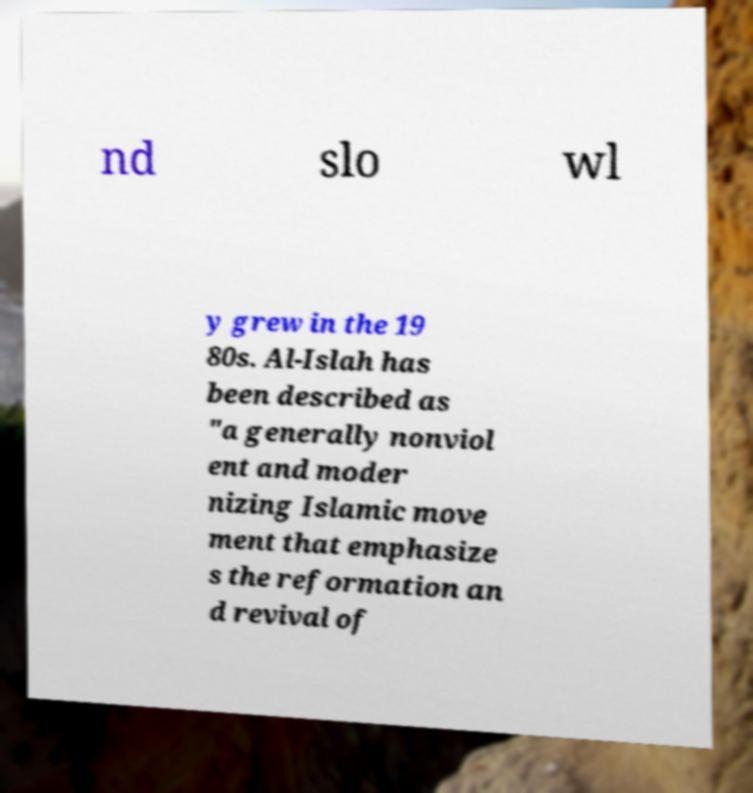Please read and relay the text visible in this image. What does it say? nd slo wl y grew in the 19 80s. Al-Islah has been described as "a generally nonviol ent and moder nizing Islamic move ment that emphasize s the reformation an d revival of 